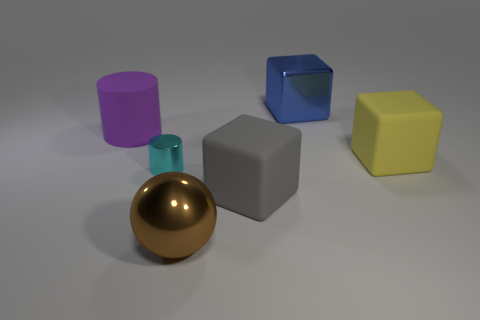What materials do the objects in the image seem to be made of? The objects in the image appear to have different textures suggesting various materials: the yellow and blue cubes seem to have a solid, matte finish, possibly resembling plastic or painted wood; the purple cylinder and the golden sphere have reflective surfaces likely indicative of a metallic material; and the grey cube seems to have a neutral, matte surface, resembling stone or untreated metal. 